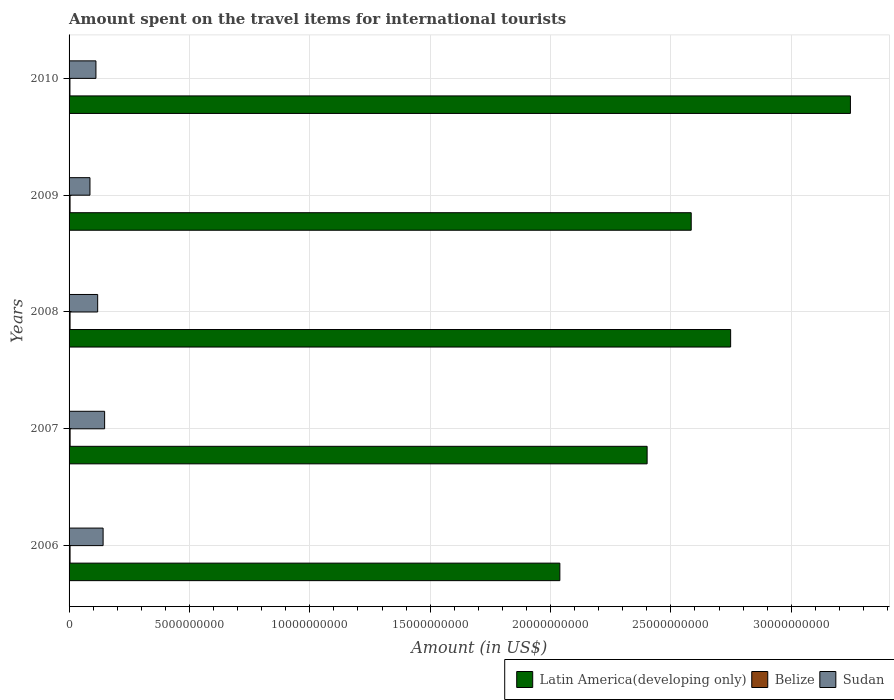Are the number of bars per tick equal to the number of legend labels?
Your answer should be very brief. Yes. Are the number of bars on each tick of the Y-axis equal?
Provide a succinct answer. Yes. How many bars are there on the 3rd tick from the bottom?
Provide a succinct answer. 3. What is the label of the 3rd group of bars from the top?
Your answer should be very brief. 2008. What is the amount spent on the travel items for international tourists in Latin America(developing only) in 2008?
Your response must be concise. 2.75e+1. Across all years, what is the maximum amount spent on the travel items for international tourists in Belize?
Your response must be concise. 4.30e+07. Across all years, what is the minimum amount spent on the travel items for international tourists in Belize?
Offer a terse response. 3.60e+07. What is the total amount spent on the travel items for international tourists in Latin America(developing only) in the graph?
Offer a terse response. 1.30e+11. What is the difference between the amount spent on the travel items for international tourists in Latin America(developing only) in 2006 and that in 2010?
Your answer should be compact. -1.21e+1. What is the difference between the amount spent on the travel items for international tourists in Belize in 2006 and the amount spent on the travel items for international tourists in Latin America(developing only) in 2009?
Provide a short and direct response. -2.58e+1. What is the average amount spent on the travel items for international tourists in Sudan per year?
Give a very brief answer. 1.21e+09. In the year 2009, what is the difference between the amount spent on the travel items for international tourists in Belize and amount spent on the travel items for international tourists in Latin America(developing only)?
Ensure brevity in your answer.  -2.58e+1. In how many years, is the amount spent on the travel items for international tourists in Belize greater than 16000000000 US$?
Your answer should be compact. 0. What is the ratio of the amount spent on the travel items for international tourists in Belize in 2006 to that in 2009?
Make the answer very short. 1. Is the amount spent on the travel items for international tourists in Belize in 2008 less than that in 2010?
Ensure brevity in your answer.  No. What is the difference between the highest and the second highest amount spent on the travel items for international tourists in Sudan?
Offer a very short reply. 6.30e+07. What is the difference between the highest and the lowest amount spent on the travel items for international tourists in Belize?
Offer a terse response. 7.00e+06. In how many years, is the amount spent on the travel items for international tourists in Belize greater than the average amount spent on the travel items for international tourists in Belize taken over all years?
Your answer should be very brief. 4. Is the sum of the amount spent on the travel items for international tourists in Belize in 2006 and 2009 greater than the maximum amount spent on the travel items for international tourists in Sudan across all years?
Give a very brief answer. No. What does the 1st bar from the top in 2008 represents?
Provide a succinct answer. Sudan. What does the 2nd bar from the bottom in 2007 represents?
Make the answer very short. Belize. Is it the case that in every year, the sum of the amount spent on the travel items for international tourists in Belize and amount spent on the travel items for international tourists in Latin America(developing only) is greater than the amount spent on the travel items for international tourists in Sudan?
Offer a terse response. Yes. How many bars are there?
Offer a very short reply. 15. Are all the bars in the graph horizontal?
Provide a short and direct response. Yes. How many years are there in the graph?
Your response must be concise. 5. What is the difference between two consecutive major ticks on the X-axis?
Your answer should be compact. 5.00e+09. Are the values on the major ticks of X-axis written in scientific E-notation?
Your response must be concise. No. Does the graph contain any zero values?
Provide a succinct answer. No. Where does the legend appear in the graph?
Offer a very short reply. Bottom right. What is the title of the graph?
Ensure brevity in your answer.  Amount spent on the travel items for international tourists. What is the label or title of the Y-axis?
Provide a succinct answer. Years. What is the Amount (in US$) of Latin America(developing only) in 2006?
Your answer should be very brief. 2.04e+1. What is the Amount (in US$) in Belize in 2006?
Your answer should be very brief. 4.10e+07. What is the Amount (in US$) in Sudan in 2006?
Make the answer very short. 1.41e+09. What is the Amount (in US$) of Latin America(developing only) in 2007?
Give a very brief answer. 2.40e+1. What is the Amount (in US$) in Belize in 2007?
Keep it short and to the point. 4.30e+07. What is the Amount (in US$) of Sudan in 2007?
Give a very brief answer. 1.48e+09. What is the Amount (in US$) of Latin America(developing only) in 2008?
Make the answer very short. 2.75e+1. What is the Amount (in US$) of Belize in 2008?
Ensure brevity in your answer.  4.10e+07. What is the Amount (in US$) of Sudan in 2008?
Provide a succinct answer. 1.19e+09. What is the Amount (in US$) in Latin America(developing only) in 2009?
Give a very brief answer. 2.58e+1. What is the Amount (in US$) of Belize in 2009?
Provide a succinct answer. 4.10e+07. What is the Amount (in US$) in Sudan in 2009?
Provide a succinct answer. 8.68e+08. What is the Amount (in US$) in Latin America(developing only) in 2010?
Your answer should be compact. 3.25e+1. What is the Amount (in US$) in Belize in 2010?
Provide a short and direct response. 3.60e+07. What is the Amount (in US$) in Sudan in 2010?
Your answer should be very brief. 1.12e+09. Across all years, what is the maximum Amount (in US$) in Latin America(developing only)?
Keep it short and to the point. 3.25e+1. Across all years, what is the maximum Amount (in US$) of Belize?
Make the answer very short. 4.30e+07. Across all years, what is the maximum Amount (in US$) in Sudan?
Offer a terse response. 1.48e+09. Across all years, what is the minimum Amount (in US$) of Latin America(developing only)?
Provide a short and direct response. 2.04e+1. Across all years, what is the minimum Amount (in US$) in Belize?
Your response must be concise. 3.60e+07. Across all years, what is the minimum Amount (in US$) of Sudan?
Offer a very short reply. 8.68e+08. What is the total Amount (in US$) in Latin America(developing only) in the graph?
Give a very brief answer. 1.30e+11. What is the total Amount (in US$) in Belize in the graph?
Your response must be concise. 2.02e+08. What is the total Amount (in US$) of Sudan in the graph?
Ensure brevity in your answer.  6.06e+09. What is the difference between the Amount (in US$) of Latin America(developing only) in 2006 and that in 2007?
Give a very brief answer. -3.63e+09. What is the difference between the Amount (in US$) in Sudan in 2006 and that in 2007?
Your answer should be compact. -6.30e+07. What is the difference between the Amount (in US$) of Latin America(developing only) in 2006 and that in 2008?
Your answer should be compact. -7.09e+09. What is the difference between the Amount (in US$) of Belize in 2006 and that in 2008?
Ensure brevity in your answer.  0. What is the difference between the Amount (in US$) in Sudan in 2006 and that in 2008?
Your answer should be compact. 2.26e+08. What is the difference between the Amount (in US$) of Latin America(developing only) in 2006 and that in 2009?
Your answer should be compact. -5.46e+09. What is the difference between the Amount (in US$) in Sudan in 2006 and that in 2009?
Make the answer very short. 5.46e+08. What is the difference between the Amount (in US$) in Latin America(developing only) in 2006 and that in 2010?
Give a very brief answer. -1.21e+1. What is the difference between the Amount (in US$) of Sudan in 2006 and that in 2010?
Offer a terse response. 2.98e+08. What is the difference between the Amount (in US$) of Latin America(developing only) in 2007 and that in 2008?
Your answer should be compact. -3.47e+09. What is the difference between the Amount (in US$) of Sudan in 2007 and that in 2008?
Give a very brief answer. 2.89e+08. What is the difference between the Amount (in US$) in Latin America(developing only) in 2007 and that in 2009?
Make the answer very short. -1.83e+09. What is the difference between the Amount (in US$) in Belize in 2007 and that in 2009?
Give a very brief answer. 2.00e+06. What is the difference between the Amount (in US$) of Sudan in 2007 and that in 2009?
Offer a terse response. 6.09e+08. What is the difference between the Amount (in US$) of Latin America(developing only) in 2007 and that in 2010?
Provide a short and direct response. -8.44e+09. What is the difference between the Amount (in US$) in Belize in 2007 and that in 2010?
Your answer should be very brief. 7.00e+06. What is the difference between the Amount (in US$) of Sudan in 2007 and that in 2010?
Provide a succinct answer. 3.61e+08. What is the difference between the Amount (in US$) of Latin America(developing only) in 2008 and that in 2009?
Provide a succinct answer. 1.64e+09. What is the difference between the Amount (in US$) of Sudan in 2008 and that in 2009?
Offer a terse response. 3.20e+08. What is the difference between the Amount (in US$) of Latin America(developing only) in 2008 and that in 2010?
Give a very brief answer. -4.98e+09. What is the difference between the Amount (in US$) of Belize in 2008 and that in 2010?
Give a very brief answer. 5.00e+06. What is the difference between the Amount (in US$) in Sudan in 2008 and that in 2010?
Offer a very short reply. 7.20e+07. What is the difference between the Amount (in US$) in Latin America(developing only) in 2009 and that in 2010?
Offer a terse response. -6.61e+09. What is the difference between the Amount (in US$) in Belize in 2009 and that in 2010?
Give a very brief answer. 5.00e+06. What is the difference between the Amount (in US$) in Sudan in 2009 and that in 2010?
Offer a terse response. -2.48e+08. What is the difference between the Amount (in US$) in Latin America(developing only) in 2006 and the Amount (in US$) in Belize in 2007?
Ensure brevity in your answer.  2.03e+1. What is the difference between the Amount (in US$) of Latin America(developing only) in 2006 and the Amount (in US$) of Sudan in 2007?
Make the answer very short. 1.89e+1. What is the difference between the Amount (in US$) in Belize in 2006 and the Amount (in US$) in Sudan in 2007?
Offer a very short reply. -1.44e+09. What is the difference between the Amount (in US$) in Latin America(developing only) in 2006 and the Amount (in US$) in Belize in 2008?
Keep it short and to the point. 2.03e+1. What is the difference between the Amount (in US$) of Latin America(developing only) in 2006 and the Amount (in US$) of Sudan in 2008?
Make the answer very short. 1.92e+1. What is the difference between the Amount (in US$) in Belize in 2006 and the Amount (in US$) in Sudan in 2008?
Offer a terse response. -1.15e+09. What is the difference between the Amount (in US$) in Latin America(developing only) in 2006 and the Amount (in US$) in Belize in 2009?
Keep it short and to the point. 2.03e+1. What is the difference between the Amount (in US$) of Latin America(developing only) in 2006 and the Amount (in US$) of Sudan in 2009?
Keep it short and to the point. 1.95e+1. What is the difference between the Amount (in US$) of Belize in 2006 and the Amount (in US$) of Sudan in 2009?
Your answer should be compact. -8.27e+08. What is the difference between the Amount (in US$) in Latin America(developing only) in 2006 and the Amount (in US$) in Belize in 2010?
Your answer should be very brief. 2.04e+1. What is the difference between the Amount (in US$) in Latin America(developing only) in 2006 and the Amount (in US$) in Sudan in 2010?
Make the answer very short. 1.93e+1. What is the difference between the Amount (in US$) of Belize in 2006 and the Amount (in US$) of Sudan in 2010?
Give a very brief answer. -1.08e+09. What is the difference between the Amount (in US$) of Latin America(developing only) in 2007 and the Amount (in US$) of Belize in 2008?
Make the answer very short. 2.40e+1. What is the difference between the Amount (in US$) of Latin America(developing only) in 2007 and the Amount (in US$) of Sudan in 2008?
Your answer should be compact. 2.28e+1. What is the difference between the Amount (in US$) in Belize in 2007 and the Amount (in US$) in Sudan in 2008?
Your response must be concise. -1.14e+09. What is the difference between the Amount (in US$) in Latin America(developing only) in 2007 and the Amount (in US$) in Belize in 2009?
Offer a terse response. 2.40e+1. What is the difference between the Amount (in US$) in Latin America(developing only) in 2007 and the Amount (in US$) in Sudan in 2009?
Your response must be concise. 2.31e+1. What is the difference between the Amount (in US$) of Belize in 2007 and the Amount (in US$) of Sudan in 2009?
Your response must be concise. -8.25e+08. What is the difference between the Amount (in US$) in Latin America(developing only) in 2007 and the Amount (in US$) in Belize in 2010?
Make the answer very short. 2.40e+1. What is the difference between the Amount (in US$) of Latin America(developing only) in 2007 and the Amount (in US$) of Sudan in 2010?
Give a very brief answer. 2.29e+1. What is the difference between the Amount (in US$) in Belize in 2007 and the Amount (in US$) in Sudan in 2010?
Give a very brief answer. -1.07e+09. What is the difference between the Amount (in US$) of Latin America(developing only) in 2008 and the Amount (in US$) of Belize in 2009?
Keep it short and to the point. 2.74e+1. What is the difference between the Amount (in US$) of Latin America(developing only) in 2008 and the Amount (in US$) of Sudan in 2009?
Your response must be concise. 2.66e+1. What is the difference between the Amount (in US$) in Belize in 2008 and the Amount (in US$) in Sudan in 2009?
Provide a short and direct response. -8.27e+08. What is the difference between the Amount (in US$) in Latin America(developing only) in 2008 and the Amount (in US$) in Belize in 2010?
Provide a short and direct response. 2.74e+1. What is the difference between the Amount (in US$) in Latin America(developing only) in 2008 and the Amount (in US$) in Sudan in 2010?
Give a very brief answer. 2.64e+1. What is the difference between the Amount (in US$) of Belize in 2008 and the Amount (in US$) of Sudan in 2010?
Give a very brief answer. -1.08e+09. What is the difference between the Amount (in US$) in Latin America(developing only) in 2009 and the Amount (in US$) in Belize in 2010?
Provide a succinct answer. 2.58e+1. What is the difference between the Amount (in US$) in Latin America(developing only) in 2009 and the Amount (in US$) in Sudan in 2010?
Provide a succinct answer. 2.47e+1. What is the difference between the Amount (in US$) in Belize in 2009 and the Amount (in US$) in Sudan in 2010?
Provide a short and direct response. -1.08e+09. What is the average Amount (in US$) of Latin America(developing only) per year?
Offer a terse response. 2.60e+1. What is the average Amount (in US$) of Belize per year?
Give a very brief answer. 4.04e+07. What is the average Amount (in US$) in Sudan per year?
Offer a very short reply. 1.21e+09. In the year 2006, what is the difference between the Amount (in US$) in Latin America(developing only) and Amount (in US$) in Belize?
Your answer should be compact. 2.03e+1. In the year 2006, what is the difference between the Amount (in US$) of Latin America(developing only) and Amount (in US$) of Sudan?
Give a very brief answer. 1.90e+1. In the year 2006, what is the difference between the Amount (in US$) of Belize and Amount (in US$) of Sudan?
Your answer should be compact. -1.37e+09. In the year 2007, what is the difference between the Amount (in US$) of Latin America(developing only) and Amount (in US$) of Belize?
Keep it short and to the point. 2.40e+1. In the year 2007, what is the difference between the Amount (in US$) in Latin America(developing only) and Amount (in US$) in Sudan?
Keep it short and to the point. 2.25e+1. In the year 2007, what is the difference between the Amount (in US$) in Belize and Amount (in US$) in Sudan?
Offer a terse response. -1.43e+09. In the year 2008, what is the difference between the Amount (in US$) in Latin America(developing only) and Amount (in US$) in Belize?
Your response must be concise. 2.74e+1. In the year 2008, what is the difference between the Amount (in US$) in Latin America(developing only) and Amount (in US$) in Sudan?
Give a very brief answer. 2.63e+1. In the year 2008, what is the difference between the Amount (in US$) of Belize and Amount (in US$) of Sudan?
Your answer should be compact. -1.15e+09. In the year 2009, what is the difference between the Amount (in US$) in Latin America(developing only) and Amount (in US$) in Belize?
Your response must be concise. 2.58e+1. In the year 2009, what is the difference between the Amount (in US$) of Latin America(developing only) and Amount (in US$) of Sudan?
Provide a short and direct response. 2.50e+1. In the year 2009, what is the difference between the Amount (in US$) in Belize and Amount (in US$) in Sudan?
Give a very brief answer. -8.27e+08. In the year 2010, what is the difference between the Amount (in US$) of Latin America(developing only) and Amount (in US$) of Belize?
Ensure brevity in your answer.  3.24e+1. In the year 2010, what is the difference between the Amount (in US$) of Latin America(developing only) and Amount (in US$) of Sudan?
Your response must be concise. 3.13e+1. In the year 2010, what is the difference between the Amount (in US$) of Belize and Amount (in US$) of Sudan?
Provide a succinct answer. -1.08e+09. What is the ratio of the Amount (in US$) of Latin America(developing only) in 2006 to that in 2007?
Keep it short and to the point. 0.85. What is the ratio of the Amount (in US$) in Belize in 2006 to that in 2007?
Your answer should be compact. 0.95. What is the ratio of the Amount (in US$) of Sudan in 2006 to that in 2007?
Keep it short and to the point. 0.96. What is the ratio of the Amount (in US$) of Latin America(developing only) in 2006 to that in 2008?
Your answer should be very brief. 0.74. What is the ratio of the Amount (in US$) of Sudan in 2006 to that in 2008?
Provide a succinct answer. 1.19. What is the ratio of the Amount (in US$) in Latin America(developing only) in 2006 to that in 2009?
Make the answer very short. 0.79. What is the ratio of the Amount (in US$) in Belize in 2006 to that in 2009?
Ensure brevity in your answer.  1. What is the ratio of the Amount (in US$) in Sudan in 2006 to that in 2009?
Ensure brevity in your answer.  1.63. What is the ratio of the Amount (in US$) of Latin America(developing only) in 2006 to that in 2010?
Your answer should be compact. 0.63. What is the ratio of the Amount (in US$) of Belize in 2006 to that in 2010?
Offer a very short reply. 1.14. What is the ratio of the Amount (in US$) in Sudan in 2006 to that in 2010?
Offer a terse response. 1.27. What is the ratio of the Amount (in US$) of Latin America(developing only) in 2007 to that in 2008?
Your response must be concise. 0.87. What is the ratio of the Amount (in US$) of Belize in 2007 to that in 2008?
Your answer should be very brief. 1.05. What is the ratio of the Amount (in US$) in Sudan in 2007 to that in 2008?
Provide a succinct answer. 1.24. What is the ratio of the Amount (in US$) in Latin America(developing only) in 2007 to that in 2009?
Make the answer very short. 0.93. What is the ratio of the Amount (in US$) in Belize in 2007 to that in 2009?
Your answer should be compact. 1.05. What is the ratio of the Amount (in US$) of Sudan in 2007 to that in 2009?
Offer a terse response. 1.7. What is the ratio of the Amount (in US$) of Latin America(developing only) in 2007 to that in 2010?
Ensure brevity in your answer.  0.74. What is the ratio of the Amount (in US$) in Belize in 2007 to that in 2010?
Make the answer very short. 1.19. What is the ratio of the Amount (in US$) in Sudan in 2007 to that in 2010?
Ensure brevity in your answer.  1.32. What is the ratio of the Amount (in US$) in Latin America(developing only) in 2008 to that in 2009?
Your response must be concise. 1.06. What is the ratio of the Amount (in US$) in Belize in 2008 to that in 2009?
Your answer should be very brief. 1. What is the ratio of the Amount (in US$) of Sudan in 2008 to that in 2009?
Provide a short and direct response. 1.37. What is the ratio of the Amount (in US$) of Latin America(developing only) in 2008 to that in 2010?
Your response must be concise. 0.85. What is the ratio of the Amount (in US$) in Belize in 2008 to that in 2010?
Ensure brevity in your answer.  1.14. What is the ratio of the Amount (in US$) of Sudan in 2008 to that in 2010?
Provide a short and direct response. 1.06. What is the ratio of the Amount (in US$) of Latin America(developing only) in 2009 to that in 2010?
Your answer should be compact. 0.8. What is the ratio of the Amount (in US$) of Belize in 2009 to that in 2010?
Offer a very short reply. 1.14. What is the difference between the highest and the second highest Amount (in US$) in Latin America(developing only)?
Your answer should be compact. 4.98e+09. What is the difference between the highest and the second highest Amount (in US$) of Sudan?
Give a very brief answer. 6.30e+07. What is the difference between the highest and the lowest Amount (in US$) of Latin America(developing only)?
Offer a very short reply. 1.21e+1. What is the difference between the highest and the lowest Amount (in US$) of Belize?
Your answer should be compact. 7.00e+06. What is the difference between the highest and the lowest Amount (in US$) in Sudan?
Offer a terse response. 6.09e+08. 